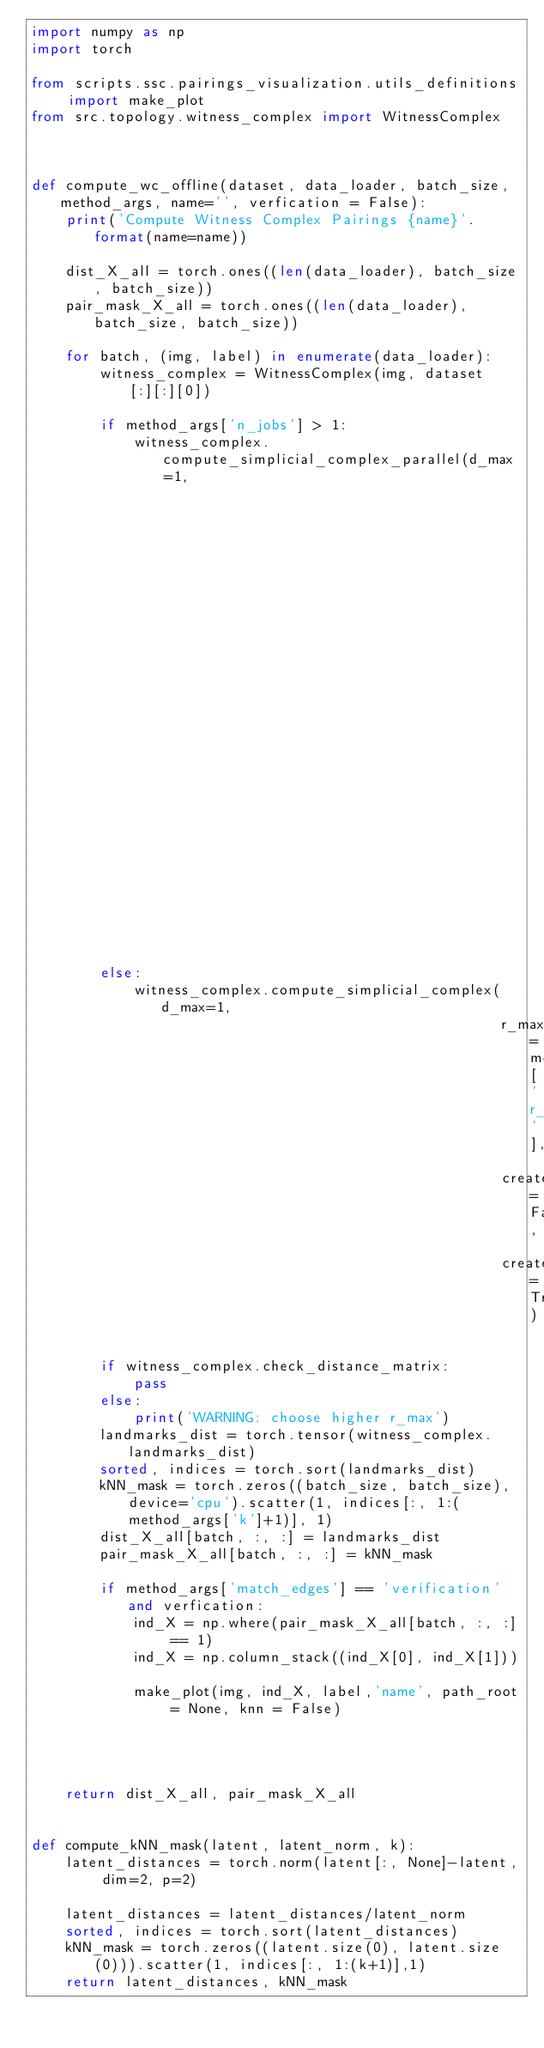Convert code to text. <code><loc_0><loc_0><loc_500><loc_500><_Python_>import numpy as np
import torch

from scripts.ssc.pairings_visualization.utils_definitions import make_plot
from src.topology.witness_complex import WitnessComplex



def compute_wc_offline(dataset, data_loader, batch_size, method_args, name='', verfication = False):
    print('Compute Witness Complex Pairings {name}'.format(name=name))

    dist_X_all = torch.ones((len(data_loader), batch_size, batch_size))
    pair_mask_X_all = torch.ones((len(data_loader), batch_size, batch_size))

    for batch, (img, label) in enumerate(data_loader):
        witness_complex = WitnessComplex(img, dataset[:][:][0])

        if method_args['n_jobs'] > 1:
            witness_complex.compute_simplicial_complex_parallel(d_max=1,
                                                                r_max=method_args['r_max'],
                                                                create_simplex_tree=False,
                                                                create_metric=True,
                                                                n_jobs=method_args['n_jobs'])
        else:
            witness_complex.compute_simplicial_complex(d_max=1,
                                                       r_max=method_args['r_max'],
                                                       create_simplex_tree=False,
                                                       create_metric=True)

        if witness_complex.check_distance_matrix:
            pass
        else:
            print('WARNING: choose higher r_max')
        landmarks_dist = torch.tensor(witness_complex.landmarks_dist)
        sorted, indices = torch.sort(landmarks_dist)
        kNN_mask = torch.zeros((batch_size, batch_size), device='cpu').scatter(1, indices[:, 1:(method_args['k']+1)], 1)
        dist_X_all[batch, :, :] = landmarks_dist
        pair_mask_X_all[batch, :, :] = kNN_mask

        if method_args['match_edges'] == 'verification' and verfication:
            ind_X = np.where(pair_mask_X_all[batch, :, :] == 1)
            ind_X = np.column_stack((ind_X[0], ind_X[1]))

            make_plot(img, ind_X, label,'name', path_root = None, knn = False)




    return dist_X_all, pair_mask_X_all


def compute_kNN_mask(latent, latent_norm, k):
    latent_distances = torch.norm(latent[:, None]-latent, dim=2, p=2)
    
    latent_distances = latent_distances/latent_norm
    sorted, indices = torch.sort(latent_distances)
    kNN_mask = torch.zeros((latent.size(0), latent.size(0))).scatter(1, indices[:, 1:(k+1)],1)
    return latent_distances, kNN_mask
</code> 